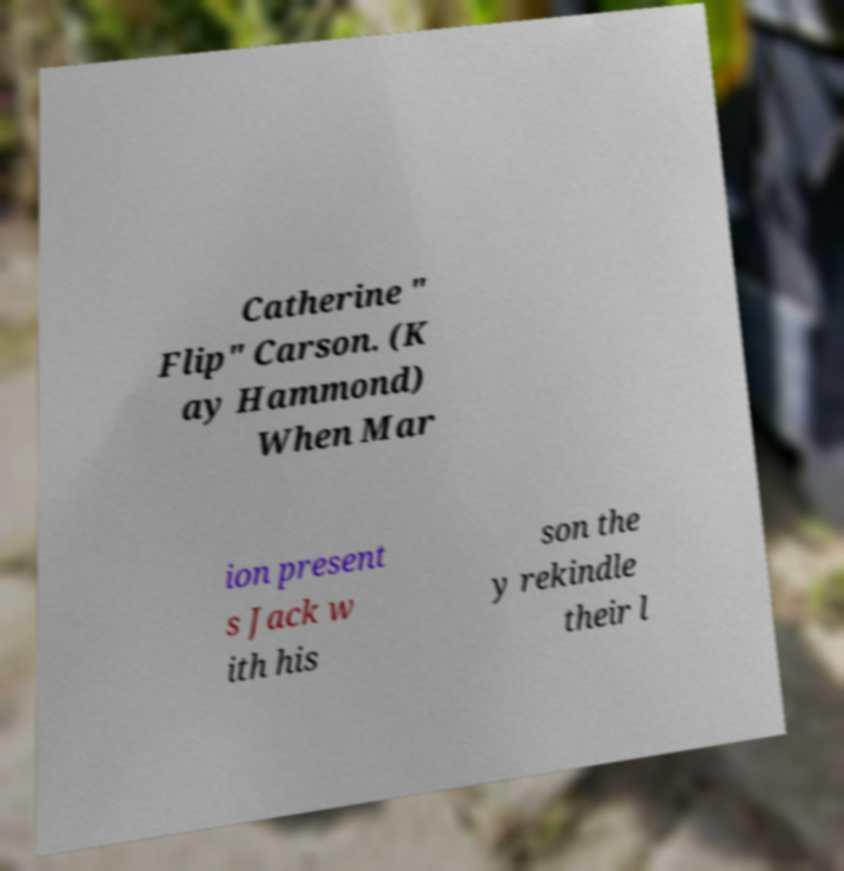Please read and relay the text visible in this image. What does it say? Catherine " Flip" Carson. (K ay Hammond) When Mar ion present s Jack w ith his son the y rekindle their l 